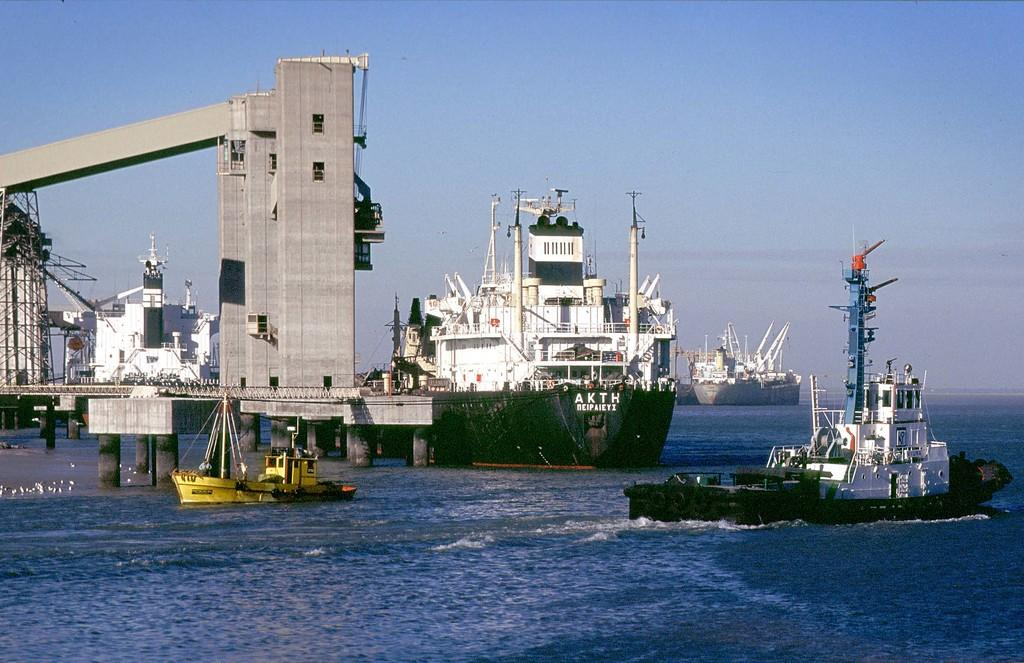<image>
Present a compact description of the photo's key features. A large green boat as the letters AKTH written on the front 